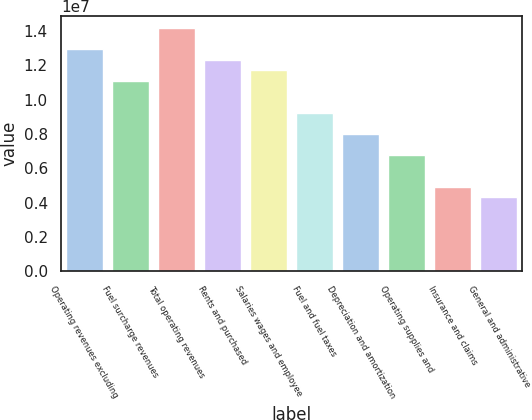Convert chart. <chart><loc_0><loc_0><loc_500><loc_500><bar_chart><fcel>Operating revenues excluding<fcel>Fuel surcharge revenues<fcel>Total operating revenues<fcel>Rents and purchased<fcel>Salaries wages and employee<fcel>Fuel and fuel taxes<fcel>Depreciation and amortization<fcel>Operating supplies and<fcel>Insurance and claims<fcel>General and administrative<nl><fcel>1.29474e+07<fcel>1.10978e+07<fcel>1.41805e+07<fcel>1.23309e+07<fcel>1.17143e+07<fcel>9.24816e+06<fcel>8.01507e+06<fcel>6.78199e+06<fcel>4.93235e+06<fcel>4.31581e+06<nl></chart> 